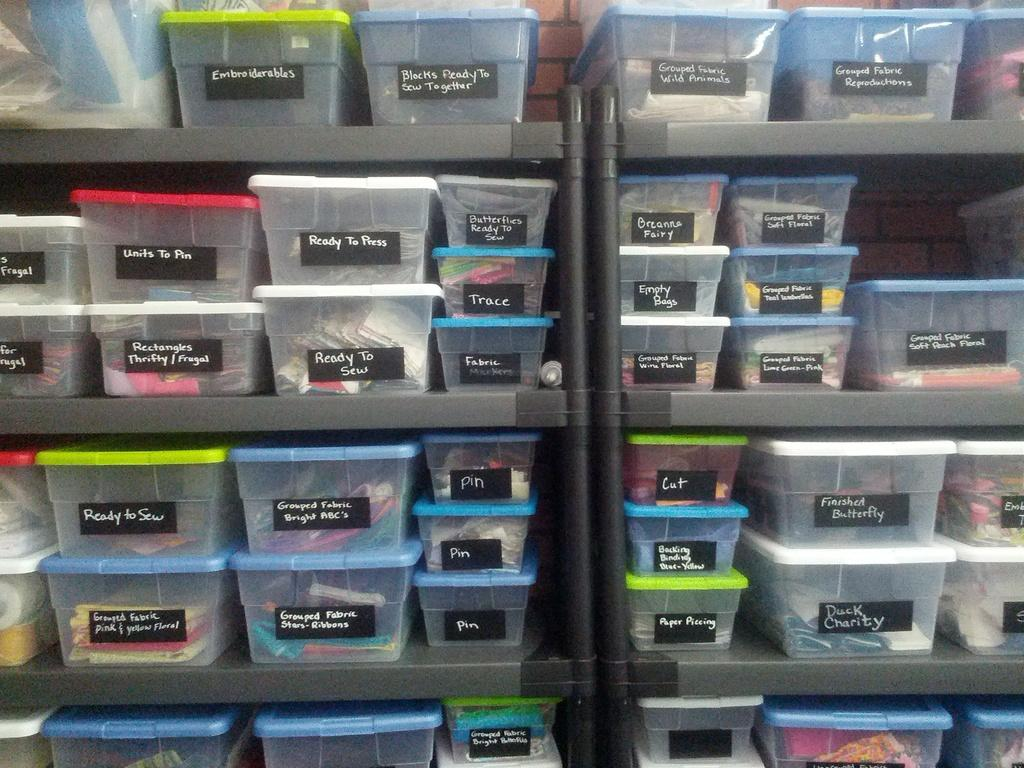What type of storage units are present in the image? There are shelves in the image. What can be found on the shelves? The shelves contain boxes of different colors. What is placed on top of the boxes? Papers are stocked on the boxes. How does the zephyr affect the arrangement of the boxes on the shelves? There is no mention of a zephyr in the image, so it cannot be determined how it would affect the arrangement of the boxes. 